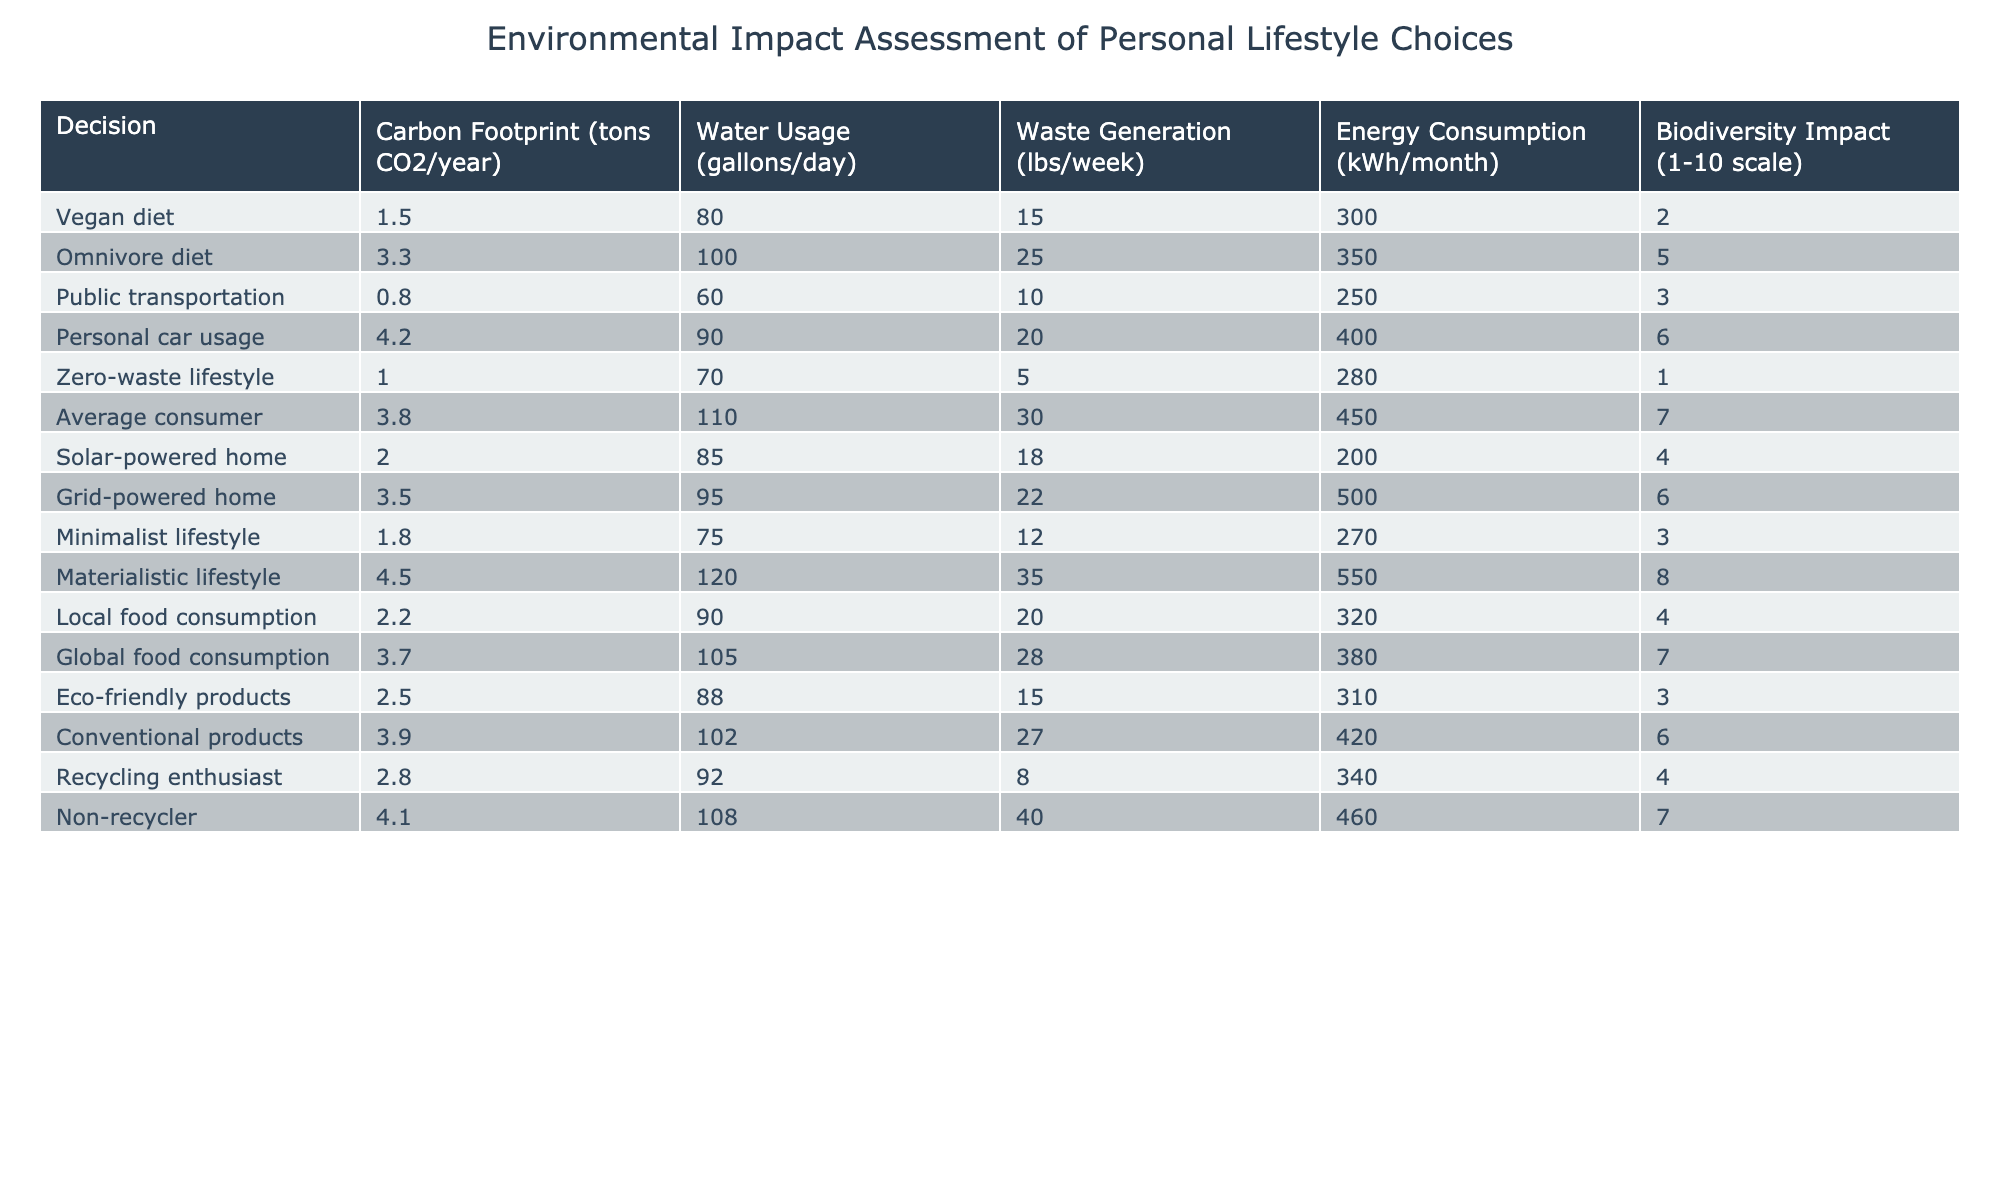What is the carbon footprint of a vegan diet? The table shows the carbon footprint of various lifestyle choices. To find the specific value for the vegan diet, I can directly refer to the related entry in the table, which states the carbon footprint is 1.5 tons CO2/year.
Answer: 1.5 tons CO2/year Which lifestyle option has the lowest waste generation? I can compare the waste generation in pounds per week across all options. The zero-waste lifestyle has the lowest waste generation listed as 5 lbs/week, making it the option with the least waste generation.
Answer: 5 lbs/week Is the biodiversity impact score for a materialistic lifestyle higher than that of a vegan lifestyle? The biodiversity impact for a materialistic lifestyle is listed as 8, while the vegan lifestyle is rated 2 on the same scale. Since 8 is greater than 2, the materialistic lifestyle does indeed have a higher impact score.
Answer: Yes What is the average water usage of the diets listed? To find the average water usage from the two diets (vegan and omnivore), I take the corresponding values 80 gallons/day (vegan) and 100 gallons/day (omnivore). Adding these gives 180 gallons/day, which I divide by 2 (the number of diets) to calculate the average, resulting in 90 gallons/day.
Answer: 90 gallons/day Which lifestyle choices have a carbon footprint less than 2 tons CO2/year? I review the table to identify all entries with a carbon footprint less than 2 tons CO2/year. The vegan diet at 1.5, zero-waste lifestyle at 1.0, and minimalist lifestyle at 1.8 each meet this criterion.
Answer: Vegan diet, Zero-waste lifestyle, Minimalist lifestyle What is the total energy consumption per month of public transportation users and those living in a solar-powered home? I find the energy consumption values for public transportation (250 kWh/month) and for a solar-powered home (200 kWh/month), then I add these two values together: 250 + 200 = 450 kWh/month. Thus, the total energy consumption for these two lifestyle choices is 450 kWh/month.
Answer: 450 kWh/month Are there more lifestyle choices that use more than 100 gallons of water per day or less? I check the water usage for all listed lifestyle choices. The ones exceeding 100 gallons/day are the omnivore diet, average consumer, and materialistic lifestyle (100, 110, and 120 respectively). There are 3 lifestyle choices that use more than 100 gallons/day and 8 that do not, so there are more options with less water usage.
Answer: Less What is the difference in biodiversity impact between the average consumer and the recycled enthusiast? I look at the biodiversity impact scores for the average consumer (7) and the recycling enthusiast (4). The difference is calculated as 7 - 4 = 3, indicating that the average consumer has a biodiversity impact score that is 3 points higher than that of the recycling enthusiast.
Answer: 3 